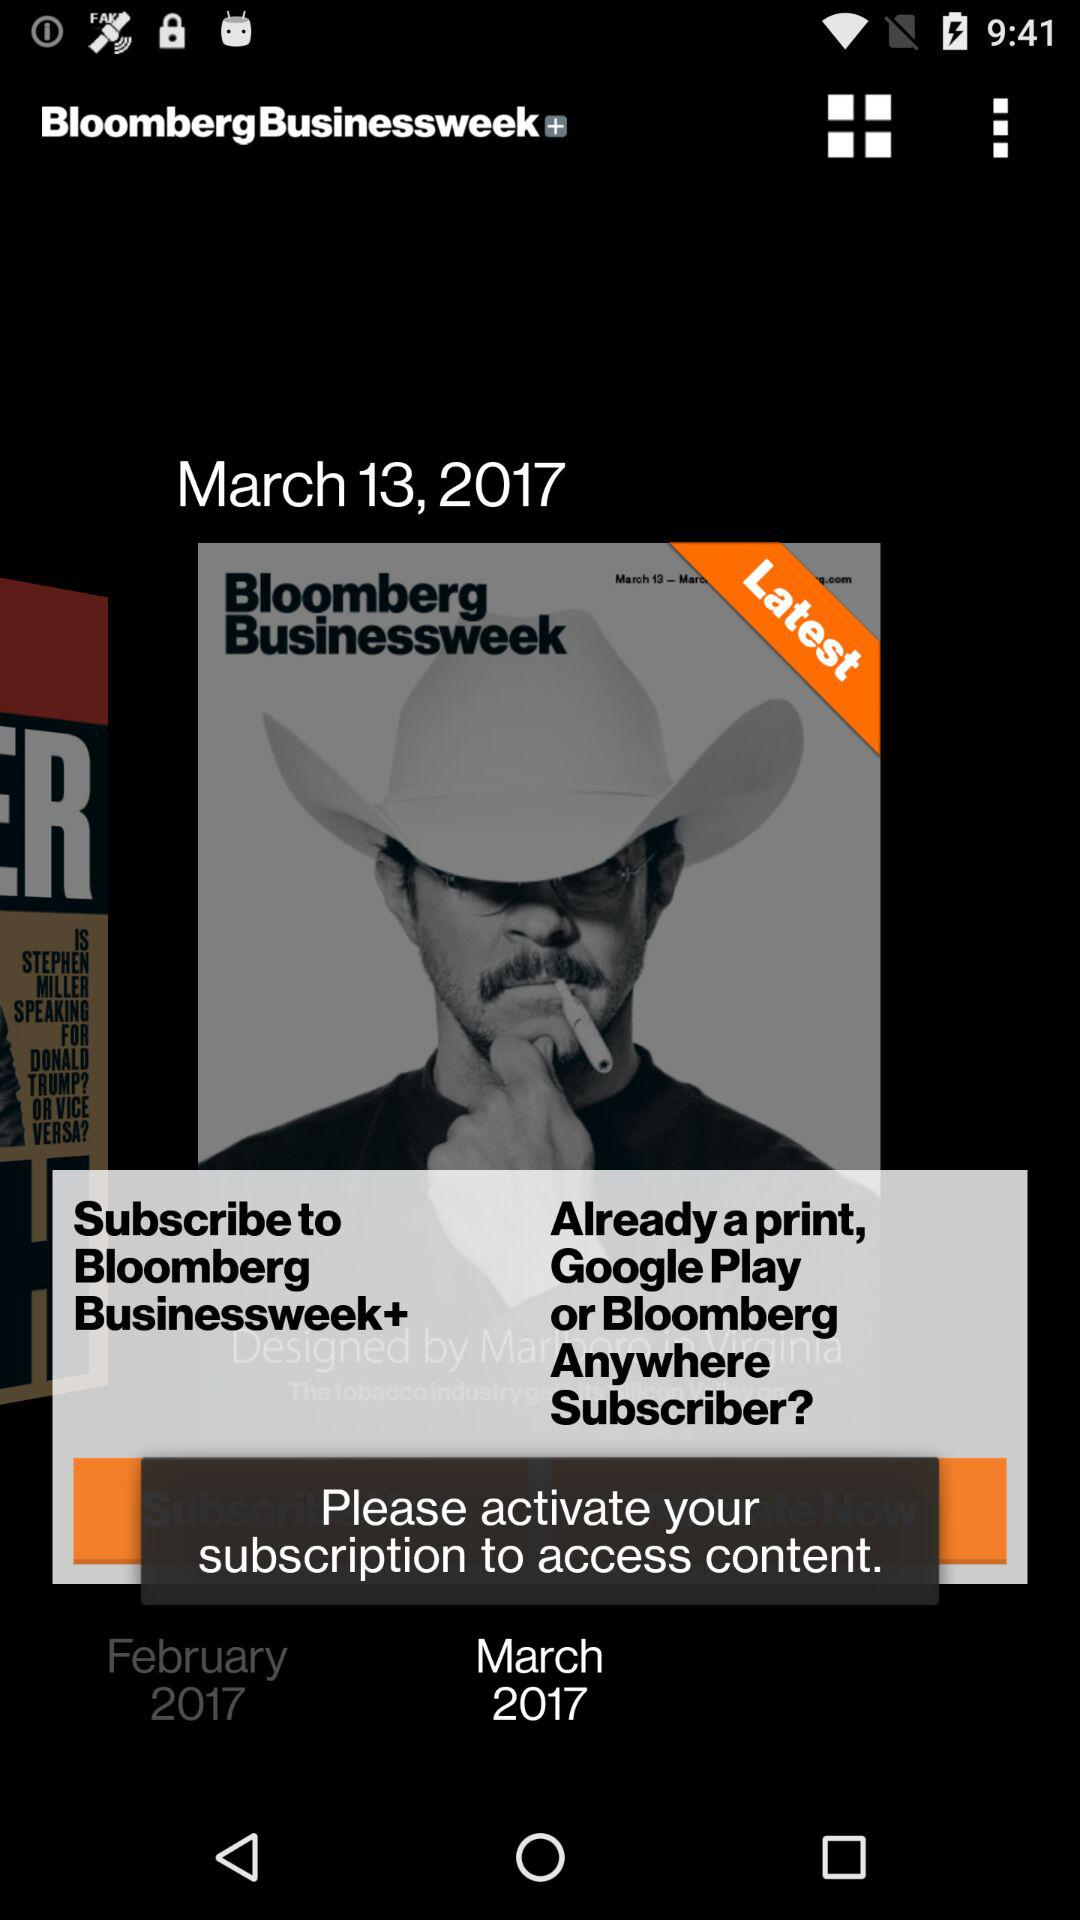What is the name of the application? The name of the application is "BloombergBusinessweek+". 